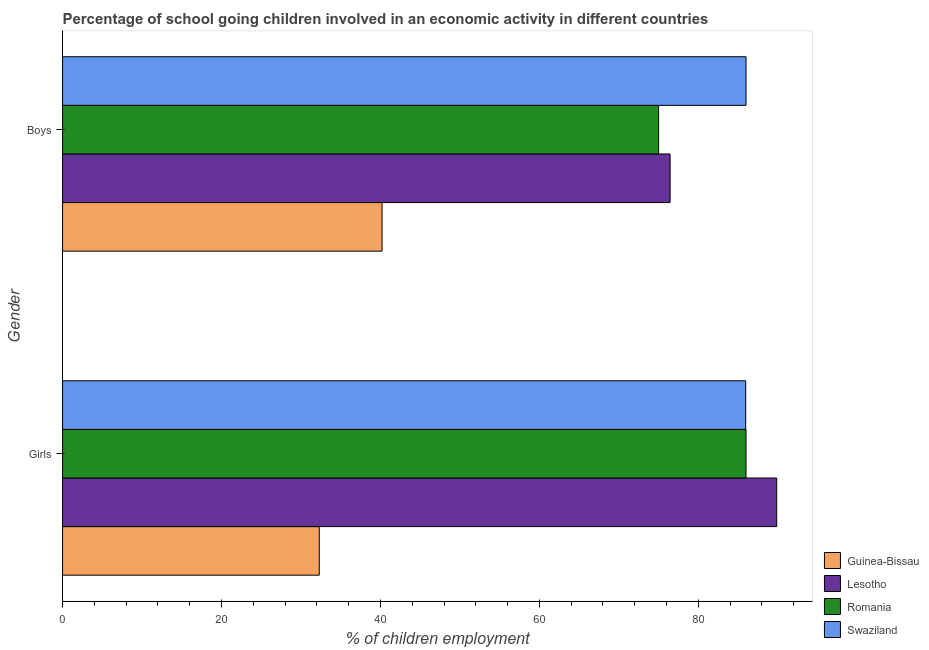How many different coloured bars are there?
Offer a very short reply. 4. What is the label of the 1st group of bars from the top?
Provide a succinct answer. Boys. What is the percentage of school going boys in Guinea-Bissau?
Give a very brief answer. 40.2. Across all countries, what is the maximum percentage of school going girls?
Provide a short and direct response. 89.86. Across all countries, what is the minimum percentage of school going boys?
Offer a very short reply. 40.2. In which country was the percentage of school going girls maximum?
Give a very brief answer. Lesotho. In which country was the percentage of school going girls minimum?
Your response must be concise. Guinea-Bissau. What is the total percentage of school going boys in the graph?
Provide a succinct answer. 277.65. What is the difference between the percentage of school going boys in Lesotho and that in Swaziland?
Provide a short and direct response. -9.56. What is the difference between the percentage of school going boys in Lesotho and the percentage of school going girls in Swaziland?
Ensure brevity in your answer.  -9.51. What is the average percentage of school going boys per country?
Keep it short and to the point. 69.41. What is the difference between the percentage of school going boys and percentage of school going girls in Guinea-Bissau?
Give a very brief answer. 7.9. In how many countries, is the percentage of school going girls greater than 8 %?
Your answer should be very brief. 4. What is the ratio of the percentage of school going boys in Romania to that in Swaziland?
Your answer should be very brief. 0.87. Is the percentage of school going girls in Guinea-Bissau less than that in Lesotho?
Make the answer very short. Yes. In how many countries, is the percentage of school going boys greater than the average percentage of school going boys taken over all countries?
Offer a very short reply. 3. What does the 4th bar from the top in Boys represents?
Your answer should be very brief. Guinea-Bissau. What does the 2nd bar from the bottom in Girls represents?
Ensure brevity in your answer.  Lesotho. How many bars are there?
Give a very brief answer. 8. What is the difference between two consecutive major ticks on the X-axis?
Your response must be concise. 20. Are the values on the major ticks of X-axis written in scientific E-notation?
Provide a short and direct response. No. Does the graph contain any zero values?
Make the answer very short. No. Does the graph contain grids?
Give a very brief answer. No. How many legend labels are there?
Make the answer very short. 4. How are the legend labels stacked?
Your answer should be very brief. Vertical. What is the title of the graph?
Your response must be concise. Percentage of school going children involved in an economic activity in different countries. What is the label or title of the X-axis?
Keep it short and to the point. % of children employment. What is the % of children employment in Guinea-Bissau in Girls?
Offer a very short reply. 32.3. What is the % of children employment in Lesotho in Girls?
Ensure brevity in your answer.  89.86. What is the % of children employment of Romania in Girls?
Keep it short and to the point. 86. What is the % of children employment of Swaziland in Girls?
Provide a short and direct response. 85.96. What is the % of children employment in Guinea-Bissau in Boys?
Keep it short and to the point. 40.2. What is the % of children employment in Lesotho in Boys?
Keep it short and to the point. 76.45. What is the % of children employment in Romania in Boys?
Give a very brief answer. 75. What is the % of children employment of Swaziland in Boys?
Provide a short and direct response. 86. Across all Gender, what is the maximum % of children employment in Guinea-Bissau?
Provide a succinct answer. 40.2. Across all Gender, what is the maximum % of children employment of Lesotho?
Give a very brief answer. 89.86. Across all Gender, what is the maximum % of children employment in Romania?
Make the answer very short. 86. Across all Gender, what is the maximum % of children employment of Swaziland?
Provide a succinct answer. 86. Across all Gender, what is the minimum % of children employment of Guinea-Bissau?
Your response must be concise. 32.3. Across all Gender, what is the minimum % of children employment in Lesotho?
Provide a succinct answer. 76.45. Across all Gender, what is the minimum % of children employment of Swaziland?
Provide a succinct answer. 85.96. What is the total % of children employment in Guinea-Bissau in the graph?
Provide a short and direct response. 72.5. What is the total % of children employment in Lesotho in the graph?
Your answer should be compact. 166.31. What is the total % of children employment of Romania in the graph?
Your response must be concise. 161. What is the total % of children employment in Swaziland in the graph?
Offer a terse response. 171.96. What is the difference between the % of children employment of Lesotho in Girls and that in Boys?
Provide a short and direct response. 13.42. What is the difference between the % of children employment of Romania in Girls and that in Boys?
Your answer should be compact. 11. What is the difference between the % of children employment of Swaziland in Girls and that in Boys?
Your answer should be compact. -0.04. What is the difference between the % of children employment of Guinea-Bissau in Girls and the % of children employment of Lesotho in Boys?
Your answer should be very brief. -44.15. What is the difference between the % of children employment of Guinea-Bissau in Girls and the % of children employment of Romania in Boys?
Your response must be concise. -42.7. What is the difference between the % of children employment of Guinea-Bissau in Girls and the % of children employment of Swaziland in Boys?
Provide a short and direct response. -53.7. What is the difference between the % of children employment in Lesotho in Girls and the % of children employment in Romania in Boys?
Offer a very short reply. 14.86. What is the difference between the % of children employment of Lesotho in Girls and the % of children employment of Swaziland in Boys?
Your answer should be very brief. 3.86. What is the difference between the % of children employment of Romania in Girls and the % of children employment of Swaziland in Boys?
Give a very brief answer. -0. What is the average % of children employment of Guinea-Bissau per Gender?
Ensure brevity in your answer.  36.25. What is the average % of children employment of Lesotho per Gender?
Offer a very short reply. 83.15. What is the average % of children employment in Romania per Gender?
Ensure brevity in your answer.  80.5. What is the average % of children employment in Swaziland per Gender?
Offer a terse response. 85.98. What is the difference between the % of children employment in Guinea-Bissau and % of children employment in Lesotho in Girls?
Keep it short and to the point. -57.56. What is the difference between the % of children employment in Guinea-Bissau and % of children employment in Romania in Girls?
Ensure brevity in your answer.  -53.7. What is the difference between the % of children employment in Guinea-Bissau and % of children employment in Swaziland in Girls?
Your response must be concise. -53.66. What is the difference between the % of children employment in Lesotho and % of children employment in Romania in Girls?
Your response must be concise. 3.86. What is the difference between the % of children employment of Lesotho and % of children employment of Swaziland in Girls?
Keep it short and to the point. 3.9. What is the difference between the % of children employment in Romania and % of children employment in Swaziland in Girls?
Offer a very short reply. 0.04. What is the difference between the % of children employment in Guinea-Bissau and % of children employment in Lesotho in Boys?
Offer a terse response. -36.25. What is the difference between the % of children employment of Guinea-Bissau and % of children employment of Romania in Boys?
Offer a terse response. -34.8. What is the difference between the % of children employment of Guinea-Bissau and % of children employment of Swaziland in Boys?
Provide a short and direct response. -45.8. What is the difference between the % of children employment in Lesotho and % of children employment in Romania in Boys?
Your answer should be compact. 1.45. What is the difference between the % of children employment of Lesotho and % of children employment of Swaziland in Boys?
Your response must be concise. -9.56. What is the difference between the % of children employment in Romania and % of children employment in Swaziland in Boys?
Provide a succinct answer. -11. What is the ratio of the % of children employment in Guinea-Bissau in Girls to that in Boys?
Provide a short and direct response. 0.8. What is the ratio of the % of children employment in Lesotho in Girls to that in Boys?
Offer a terse response. 1.18. What is the ratio of the % of children employment of Romania in Girls to that in Boys?
Offer a terse response. 1.15. What is the difference between the highest and the second highest % of children employment of Guinea-Bissau?
Provide a succinct answer. 7.9. What is the difference between the highest and the second highest % of children employment in Lesotho?
Keep it short and to the point. 13.42. What is the difference between the highest and the second highest % of children employment of Romania?
Your response must be concise. 11. What is the difference between the highest and the second highest % of children employment of Swaziland?
Make the answer very short. 0.04. What is the difference between the highest and the lowest % of children employment of Guinea-Bissau?
Keep it short and to the point. 7.9. What is the difference between the highest and the lowest % of children employment of Lesotho?
Your answer should be compact. 13.42. What is the difference between the highest and the lowest % of children employment in Swaziland?
Ensure brevity in your answer.  0.04. 